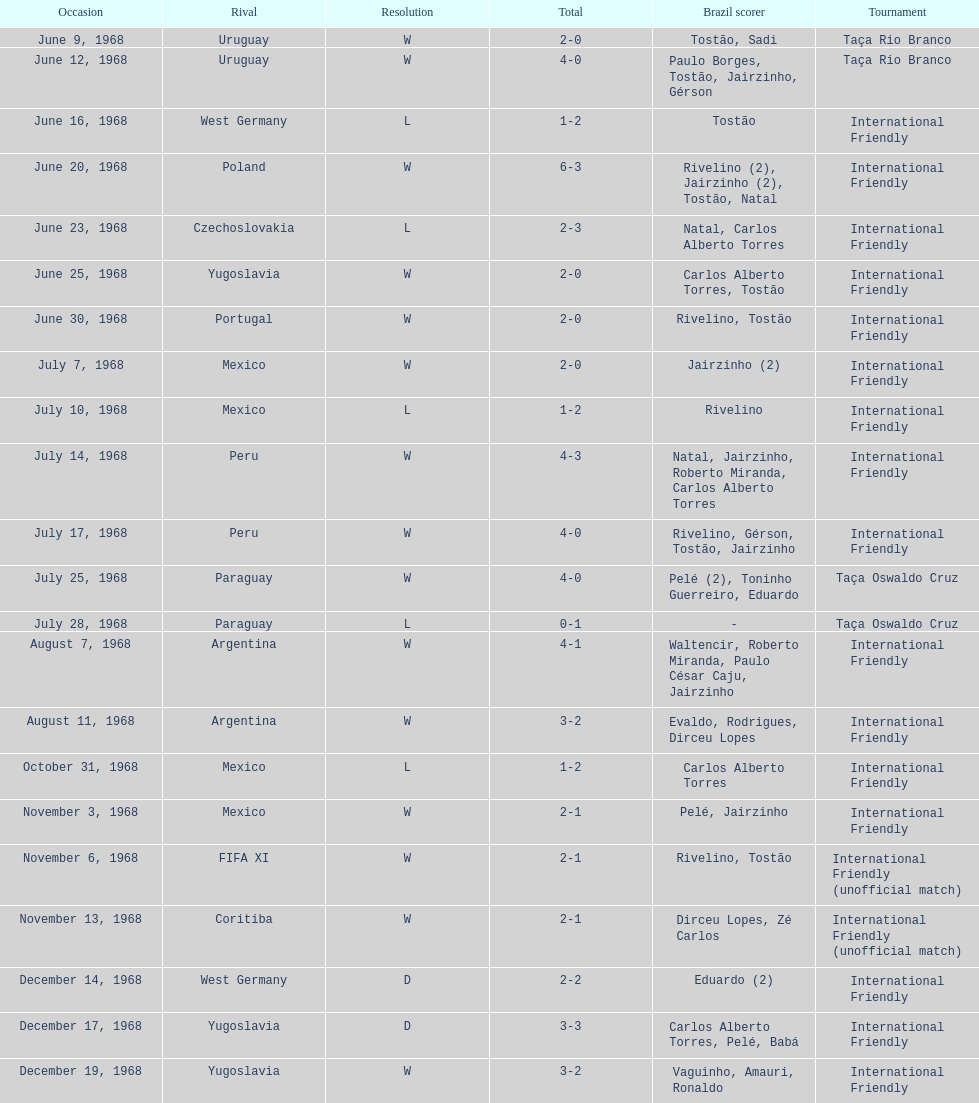Number of losses 5. 